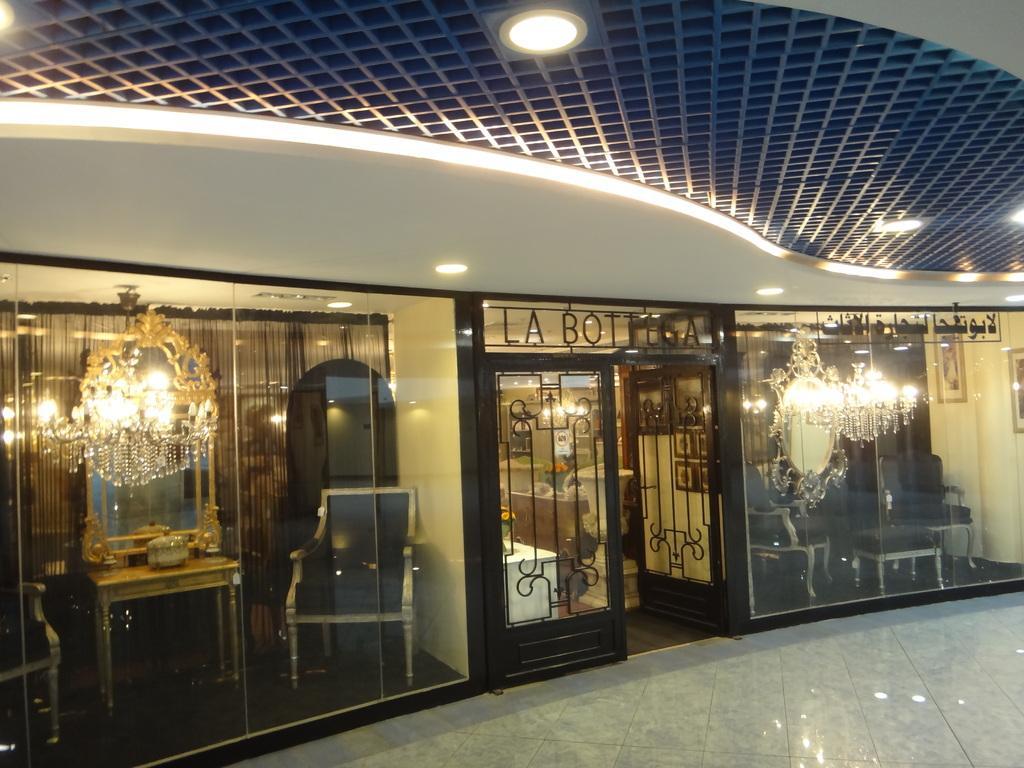Could you give a brief overview of what you see in this image? In this image we can see chairs, a box placed on a table and some mirrors through the glass doors. In the center of the image we can see a vase and a cupboard. At the top of the image we can see lights on the roof. 